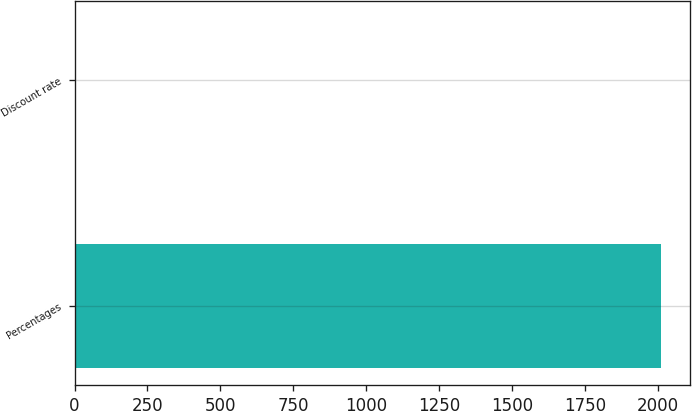Convert chart to OTSL. <chart><loc_0><loc_0><loc_500><loc_500><bar_chart><fcel>Percentages<fcel>Discount rate<nl><fcel>2009<fcel>6.25<nl></chart> 